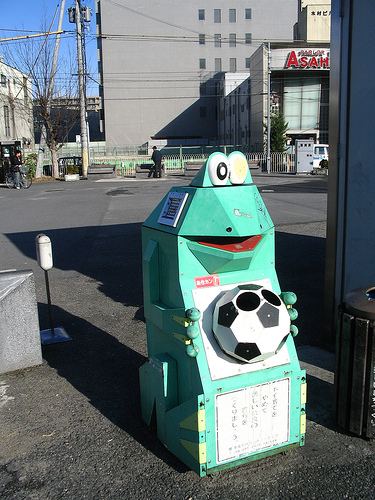<image>
Is the building behind the bike? No. The building is not behind the bike. From this viewpoint, the building appears to be positioned elsewhere in the scene. 